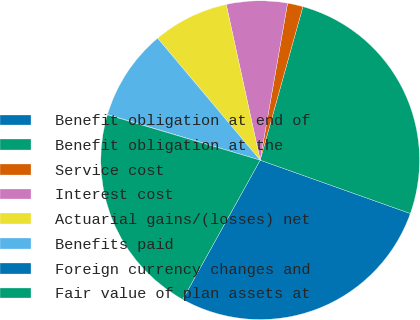Convert chart to OTSL. <chart><loc_0><loc_0><loc_500><loc_500><pie_chart><fcel>Benefit obligation at end of<fcel>Benefit obligation at the<fcel>Service cost<fcel>Interest cost<fcel>Actuarial gains/(losses) net<fcel>Benefits paid<fcel>Foreign currency changes and<fcel>Fair value of plan assets at<nl><fcel>27.65%<fcel>26.11%<fcel>1.57%<fcel>6.17%<fcel>7.71%<fcel>9.24%<fcel>0.04%<fcel>21.51%<nl></chart> 